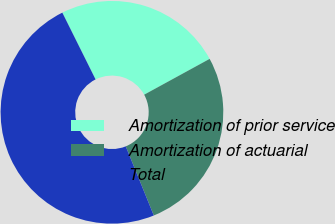<chart> <loc_0><loc_0><loc_500><loc_500><pie_chart><fcel>Amortization of prior service<fcel>Amortization of actuarial<fcel>Total<nl><fcel>24.39%<fcel>26.83%<fcel>48.78%<nl></chart> 